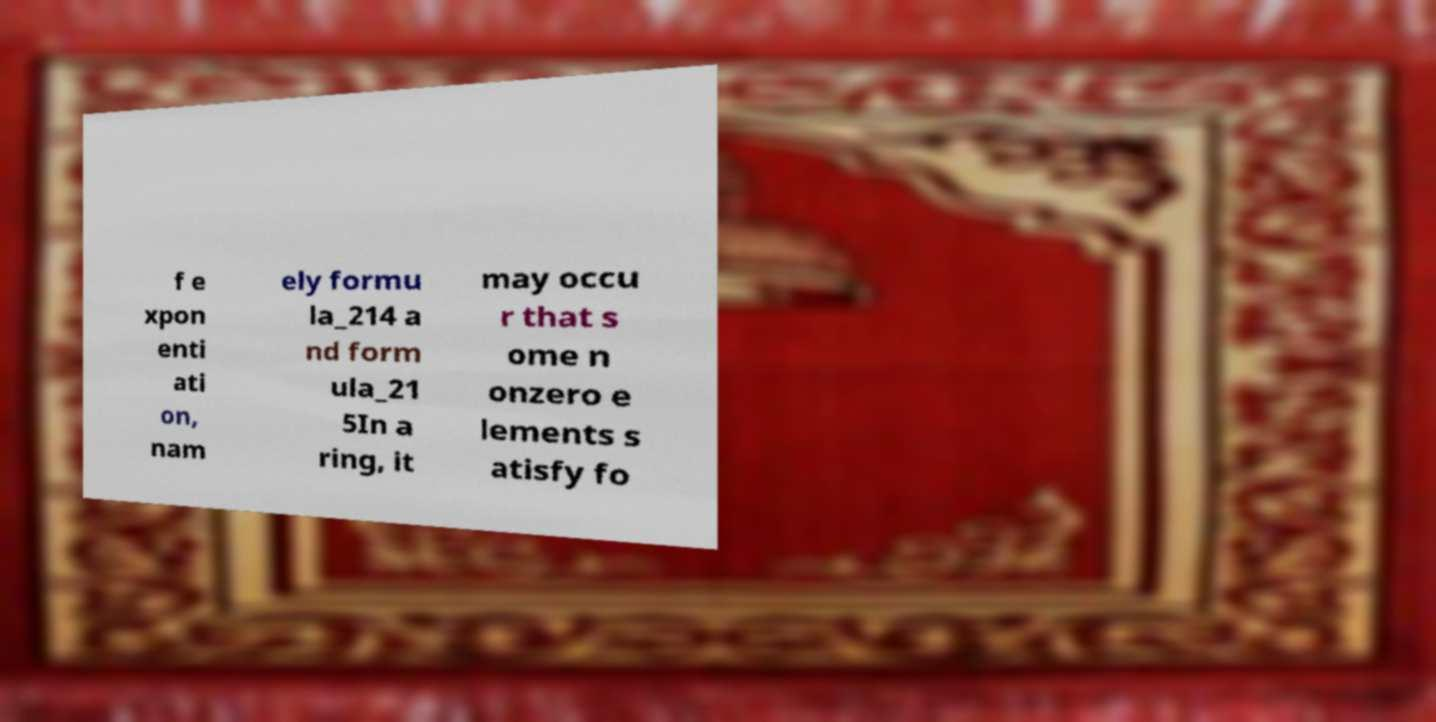For documentation purposes, I need the text within this image transcribed. Could you provide that? f e xpon enti ati on, nam ely formu la_214 a nd form ula_21 5In a ring, it may occu r that s ome n onzero e lements s atisfy fo 